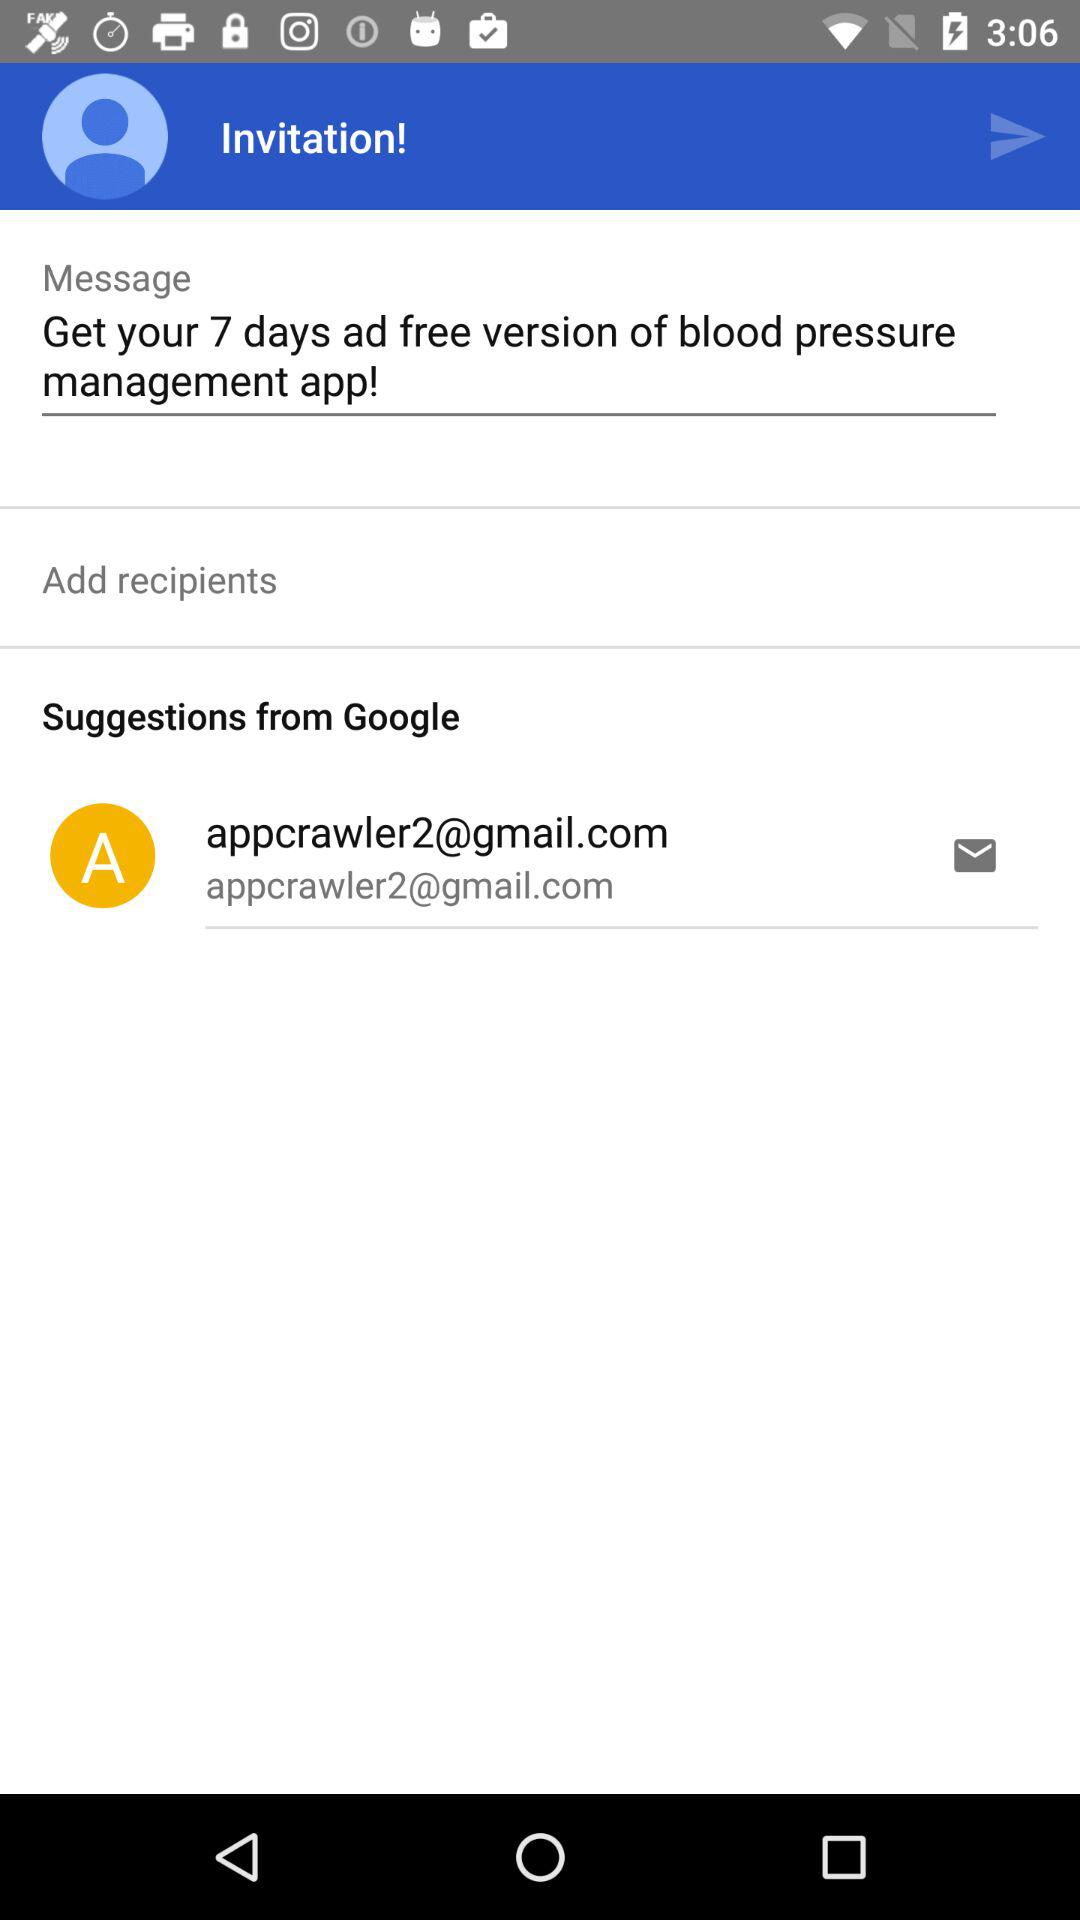Who will receive the message?
When the provided information is insufficient, respond with <no answer>. <no answer> 